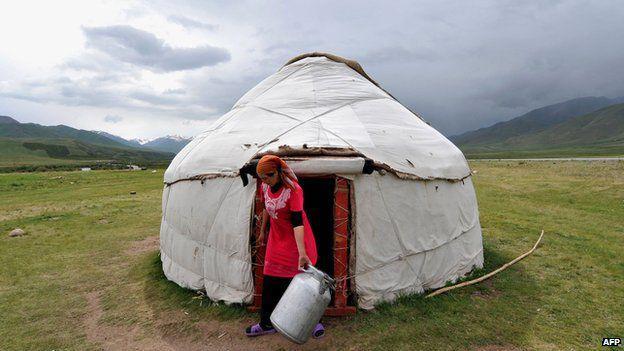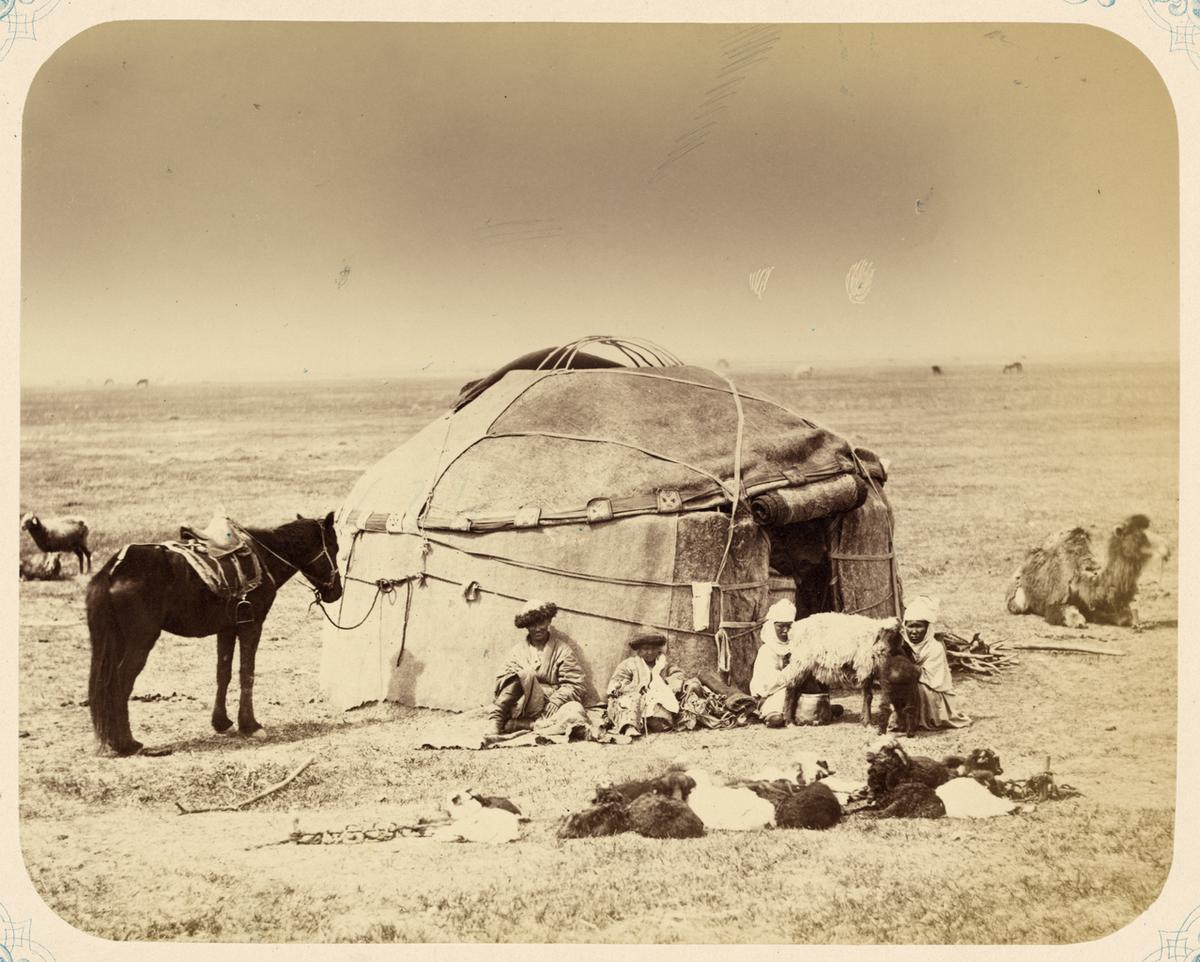The first image is the image on the left, the second image is the image on the right. Given the left and right images, does the statement "The building has a wooden ornamental door" hold true? Answer yes or no. No. The first image is the image on the left, the second image is the image on the right. Examine the images to the left and right. Is the description "A single white yurt is photographed with its door facing directly toward the camera, and at least one person stands outside the doorway." accurate? Answer yes or no. Yes. The first image is the image on the left, the second image is the image on the right. Assess this claim about the two images: "At least one person is standing outside the hut in the image on the left.". Correct or not? Answer yes or no. Yes. The first image is the image on the left, the second image is the image on the right. Examine the images to the left and right. Is the description "There are 4 or more people next to tents." accurate? Answer yes or no. Yes. 